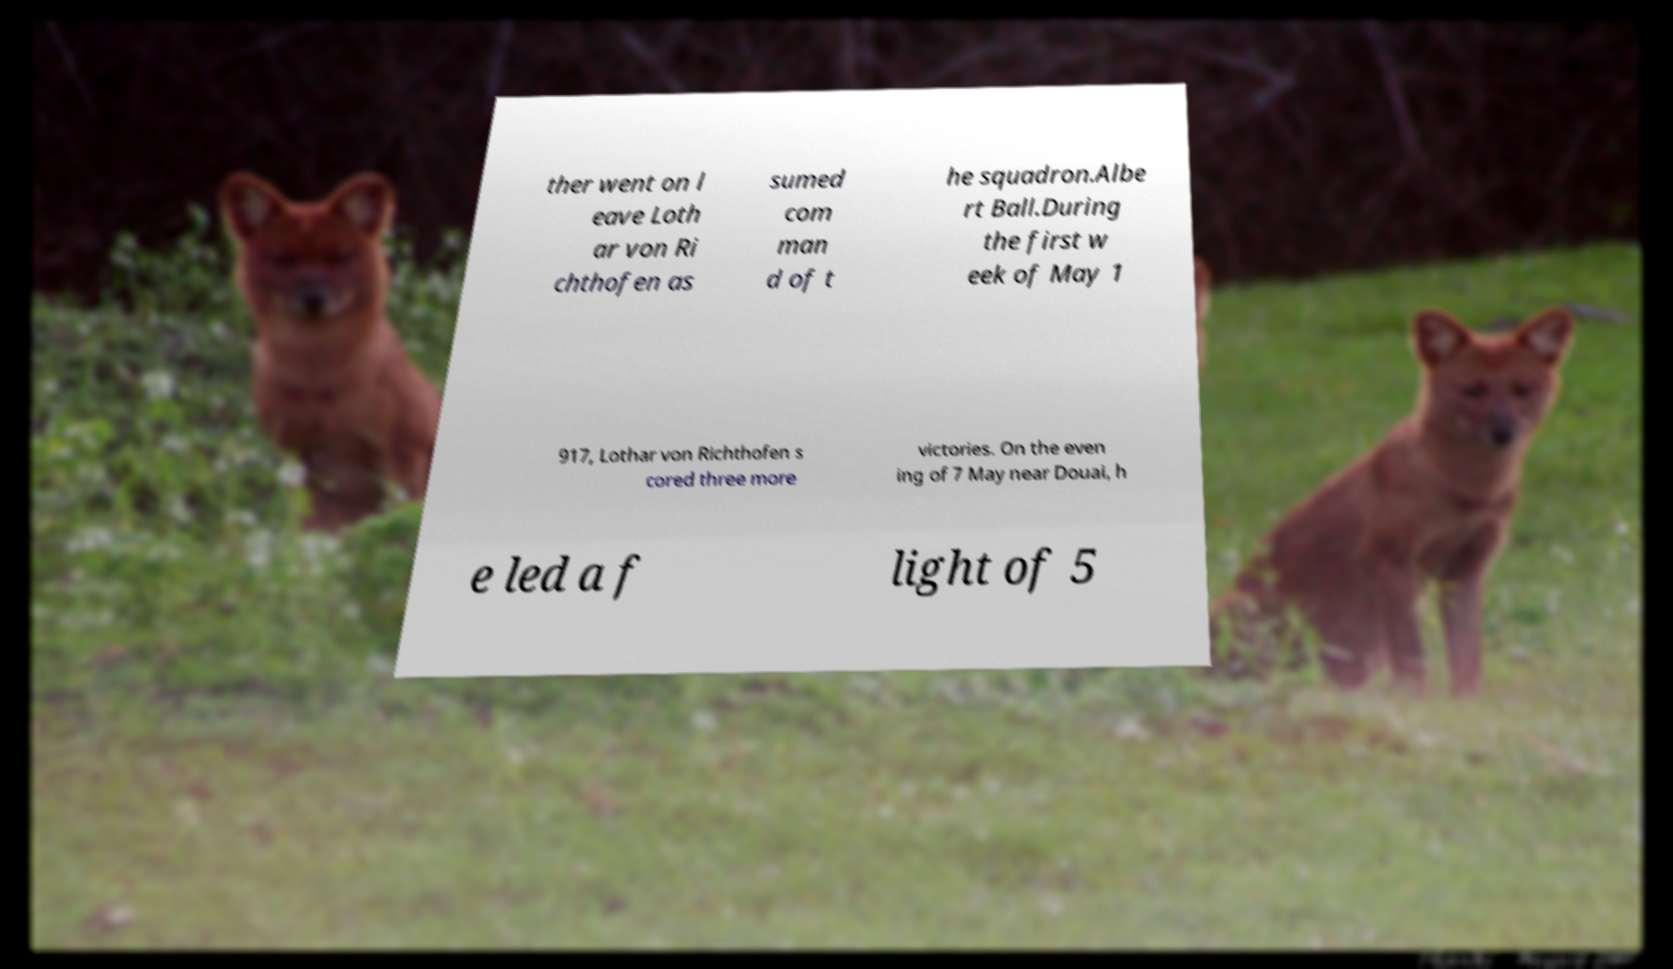Can you accurately transcribe the text from the provided image for me? ther went on l eave Loth ar von Ri chthofen as sumed com man d of t he squadron.Albe rt Ball.During the first w eek of May 1 917, Lothar von Richthofen s cored three more victories. On the even ing of 7 May near Douai, h e led a f light of 5 